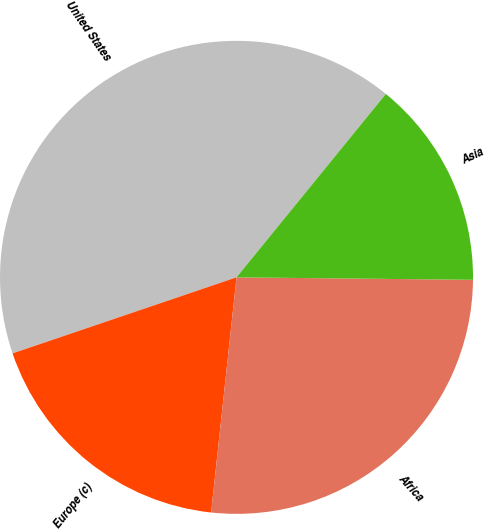Convert chart. <chart><loc_0><loc_0><loc_500><loc_500><pie_chart><fcel>United States<fcel>Europe (c)<fcel>Africa<fcel>Asia<nl><fcel>41.09%<fcel>18.08%<fcel>26.55%<fcel>14.29%<nl></chart> 